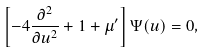Convert formula to latex. <formula><loc_0><loc_0><loc_500><loc_500>\left [ - 4 \frac { \partial ^ { 2 } } { \partial u ^ { 2 } } + 1 + \mu ^ { \prime } \right ] \Psi ( u ) = 0 ,</formula> 